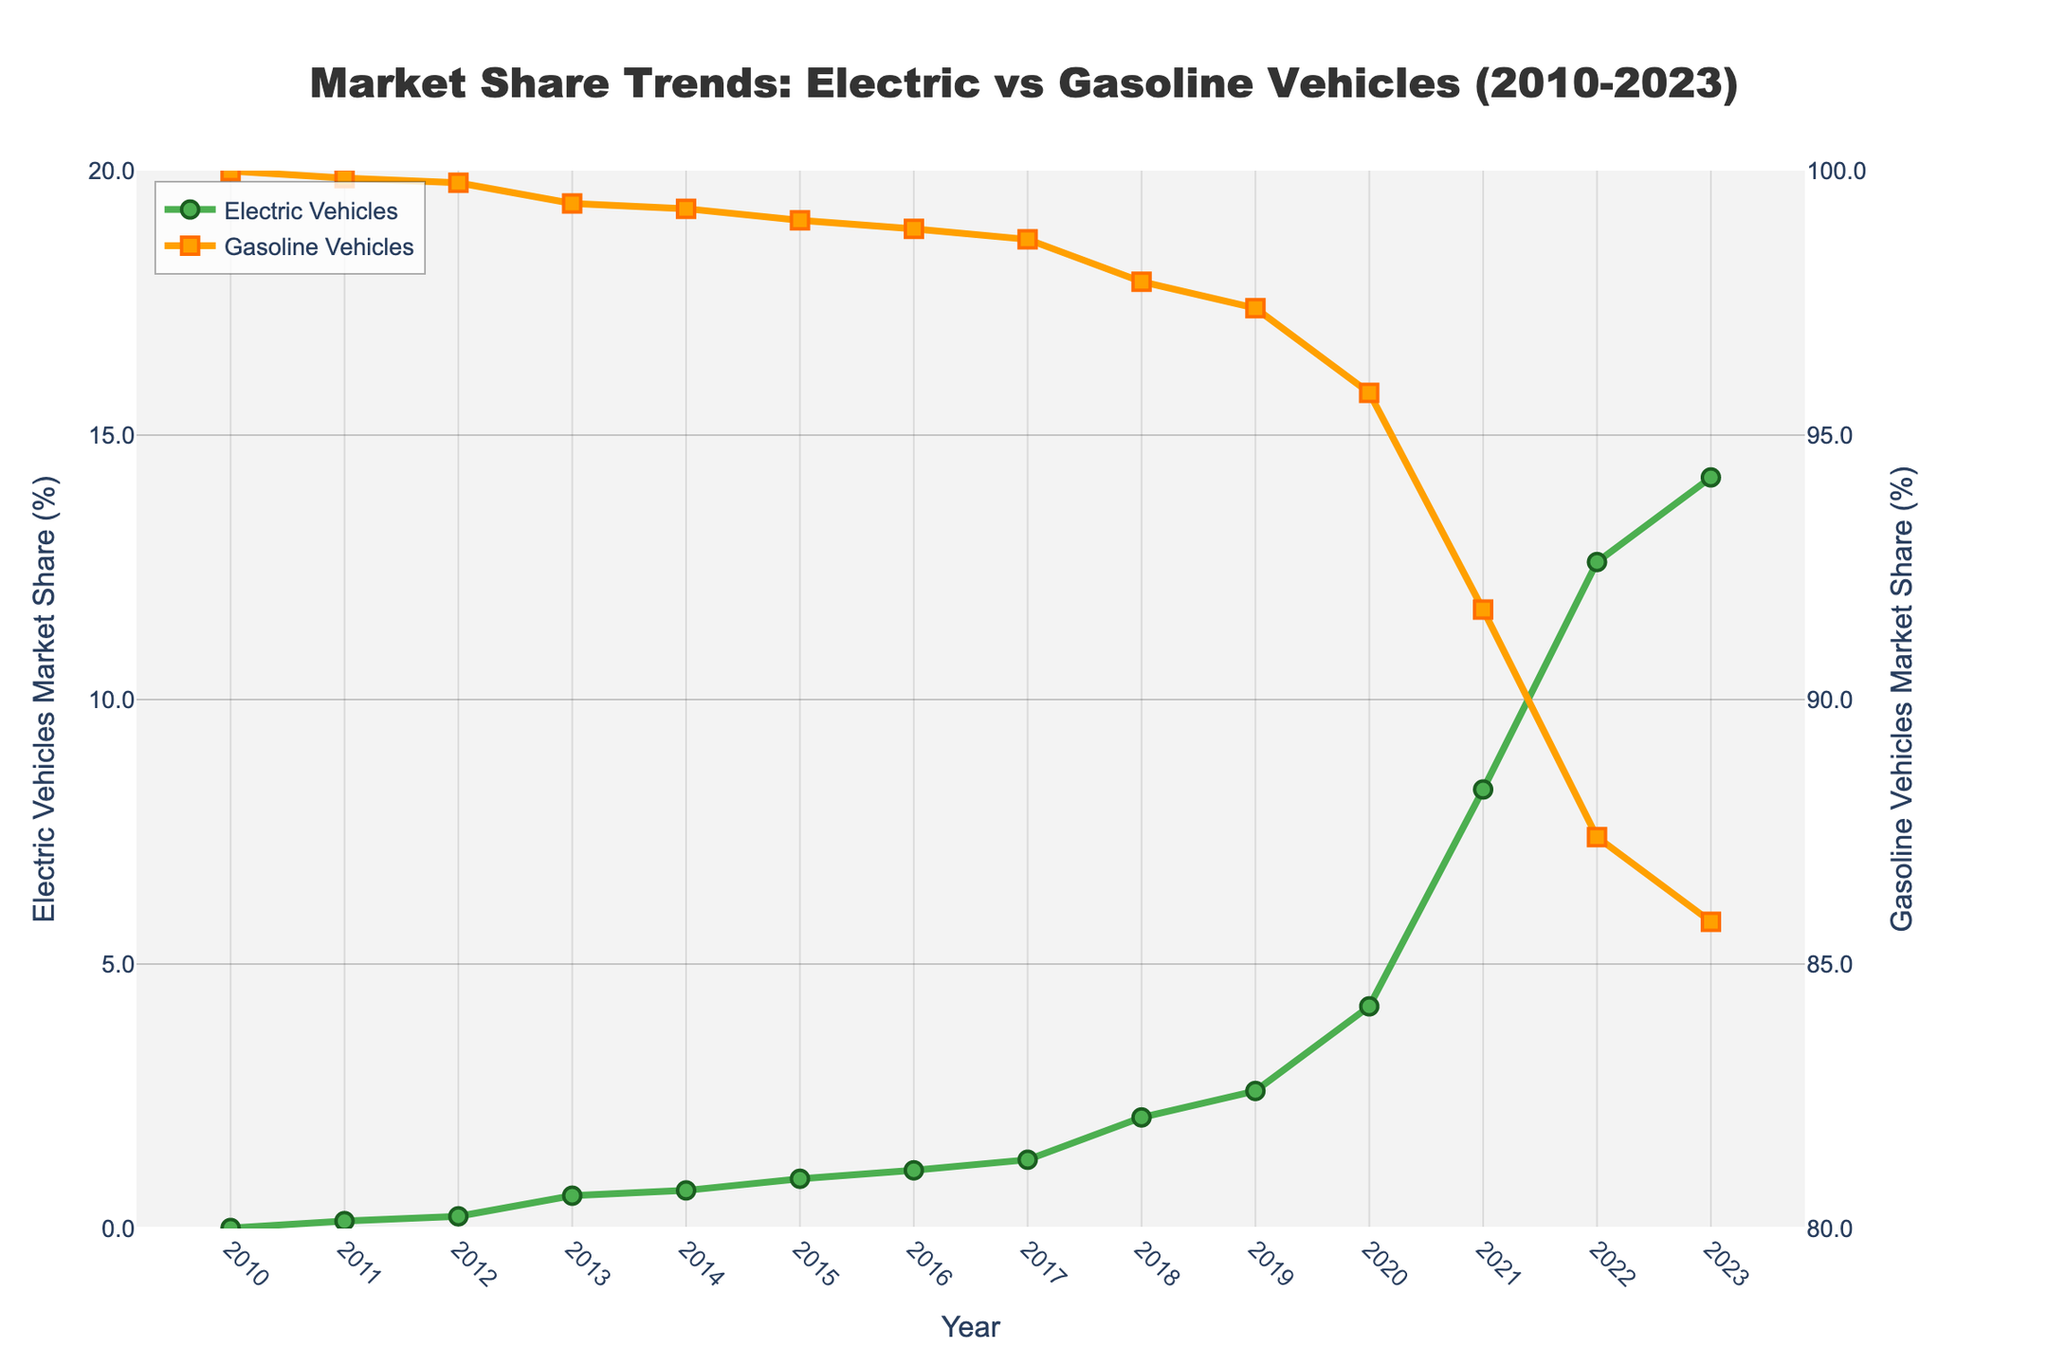What is the overall trend in market share for electric vehicles from 2010 to 2023? To determine the overall trend, observe the line for electric vehicles on the plot. Notice that it starts near 0% in 2010 and increases steadily each year, reaching above 14% in 2023.
Answer: Increasing How much did the market share for electric vehicles increase between 2010 and 2023? The market share for electric vehicles in 2010 was 0.01%, and in 2023 it is 14.2%. The increase is calculated as 14.2% - 0.01% = 14.19%.
Answer: 14.19% In what year did the market share for electric vehicles first exceed 10%? By examining the electric vehicles' line on the plot, note the year when the market share crosses the 10% mark. This happens in 2022 when the market share is 12.6%.
Answer: 2022 Which year shows the largest annual increase in market share for electric vehicles? To identify the largest annual increase, compare the increases between successive years. The largest increase appears between 2020 and 2021, from 4.2% to 8.3%, which is an increase of 4.1%.
Answer: 2021 Compare the market shares of gasoline and electric vehicles in 2018. Which was greater and by how much? In 2018, the market share for electric vehicles was 2.1%, and for gasoline vehicles, it was 97.9%. The difference is 97.9% - 2.1% = 95.8%.
Answer: Gasoline vehicles by 95.8% How did the market share for gasoline vehicles change from 2010 to 2023? From the plot, gasoline vehicles start at 99.99% in 2010 and gradually decrease to 85.8% in 2023. The change is 99.99% - 85.8% = 14.19%.
Answer: Decreased by 14.19% Which year had the smallest market share for gasoline vehicles? Examine the plot for gasoline vehicles and identify the lowest point. This occurs in 2023, with a market share of 85.8%.
Answer: 2023 What was the average market share of electric vehicles across the years 2010 to 2023? Sum the market shares of electric vehicles for each year and divide by the number of years (14). Sum: 0.01 + 0.14 + 0.23 + 0.62 + 0.72 + 0.94 + 1.10 + 1.30 + 2.10 + 2.60 + 4.20 + 8.30 + 12.60 + 14.20 = 49.06. Average: 49.06 / 14 ≈ 3.5%.
Answer: 3.5% Compare the increase in market share for electric vehicles between 2010-2015 and 2016-2021. Which period saw a larger increase? Calculate the increase in each period. 
2010-2015: 0.94% - 0.01% = 0.93%.
2016-2021: 8.3% - 1.1% = 7.2%.
The period 2016-2021 saw a larger increase.
Answer: 2016-2021 What is the difference between the peak market share of gasoline vehicles and the peak market share of electric vehicles within the given years? Peak market share for gasoline vehicles is at 99.99% in 2010. Peak market share for electric vehicles is at 14.2% in 2023. The difference is 99.99% - 14.2% = 85.79%.
Answer: 85.79% 